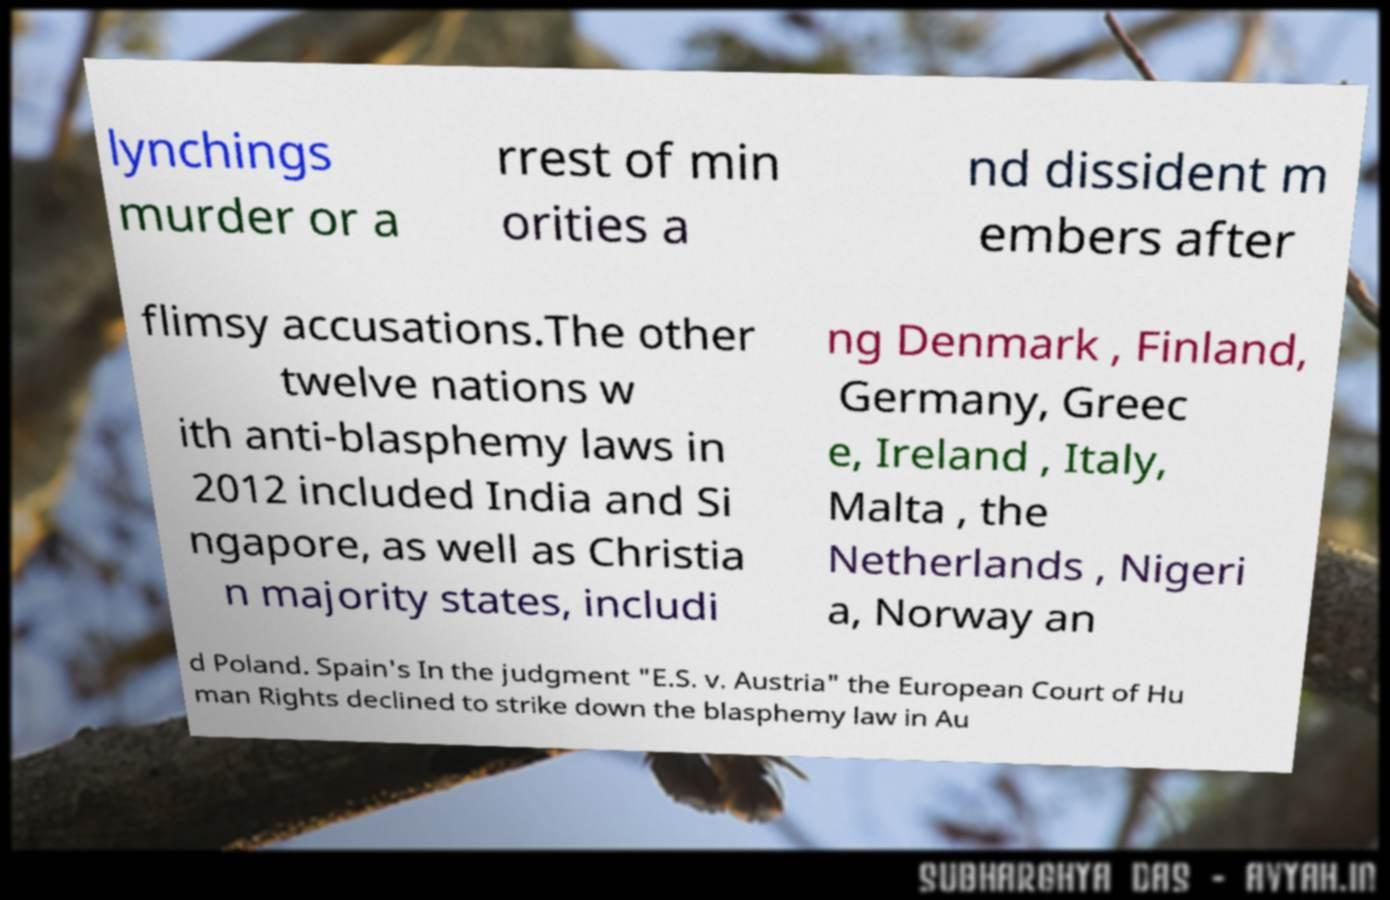Can you read and provide the text displayed in the image?This photo seems to have some interesting text. Can you extract and type it out for me? lynchings murder or a rrest of min orities a nd dissident m embers after flimsy accusations.The other twelve nations w ith anti-blasphemy laws in 2012 included India and Si ngapore, as well as Christia n majority states, includi ng Denmark , Finland, Germany, Greec e, Ireland , Italy, Malta , the Netherlands , Nigeri a, Norway an d Poland. Spain's In the judgment "E.S. v. Austria" the European Court of Hu man Rights declined to strike down the blasphemy law in Au 